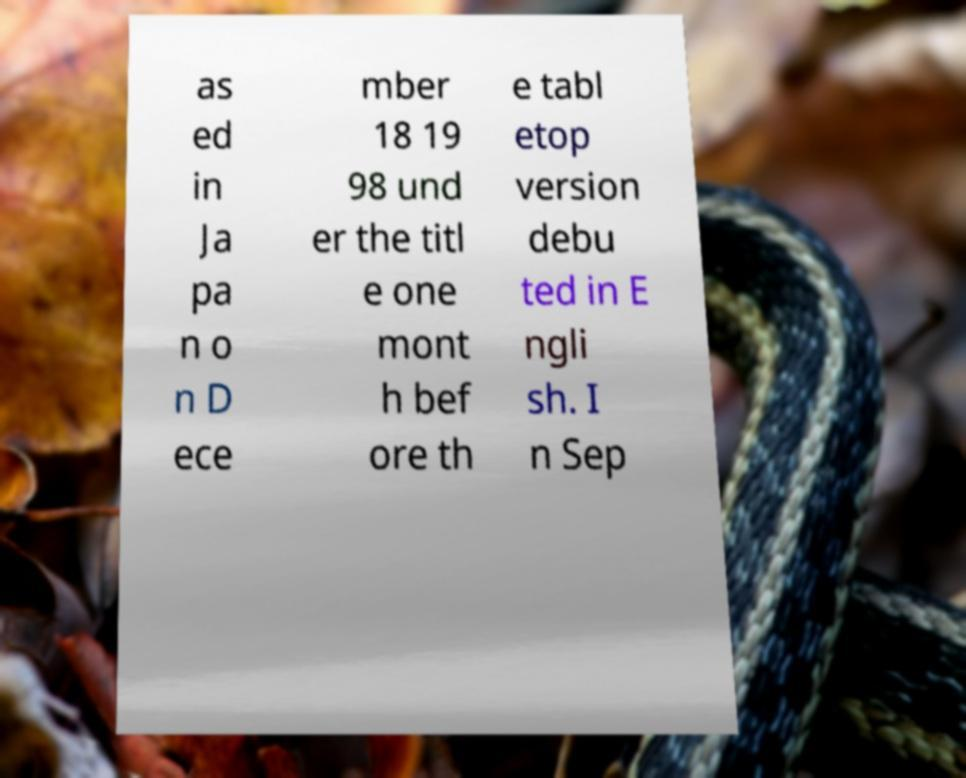For documentation purposes, I need the text within this image transcribed. Could you provide that? as ed in Ja pa n o n D ece mber 18 19 98 und er the titl e one mont h bef ore th e tabl etop version debu ted in E ngli sh. I n Sep 